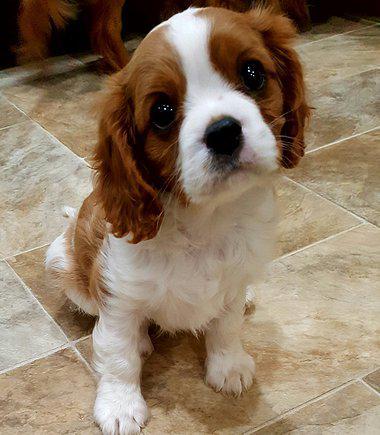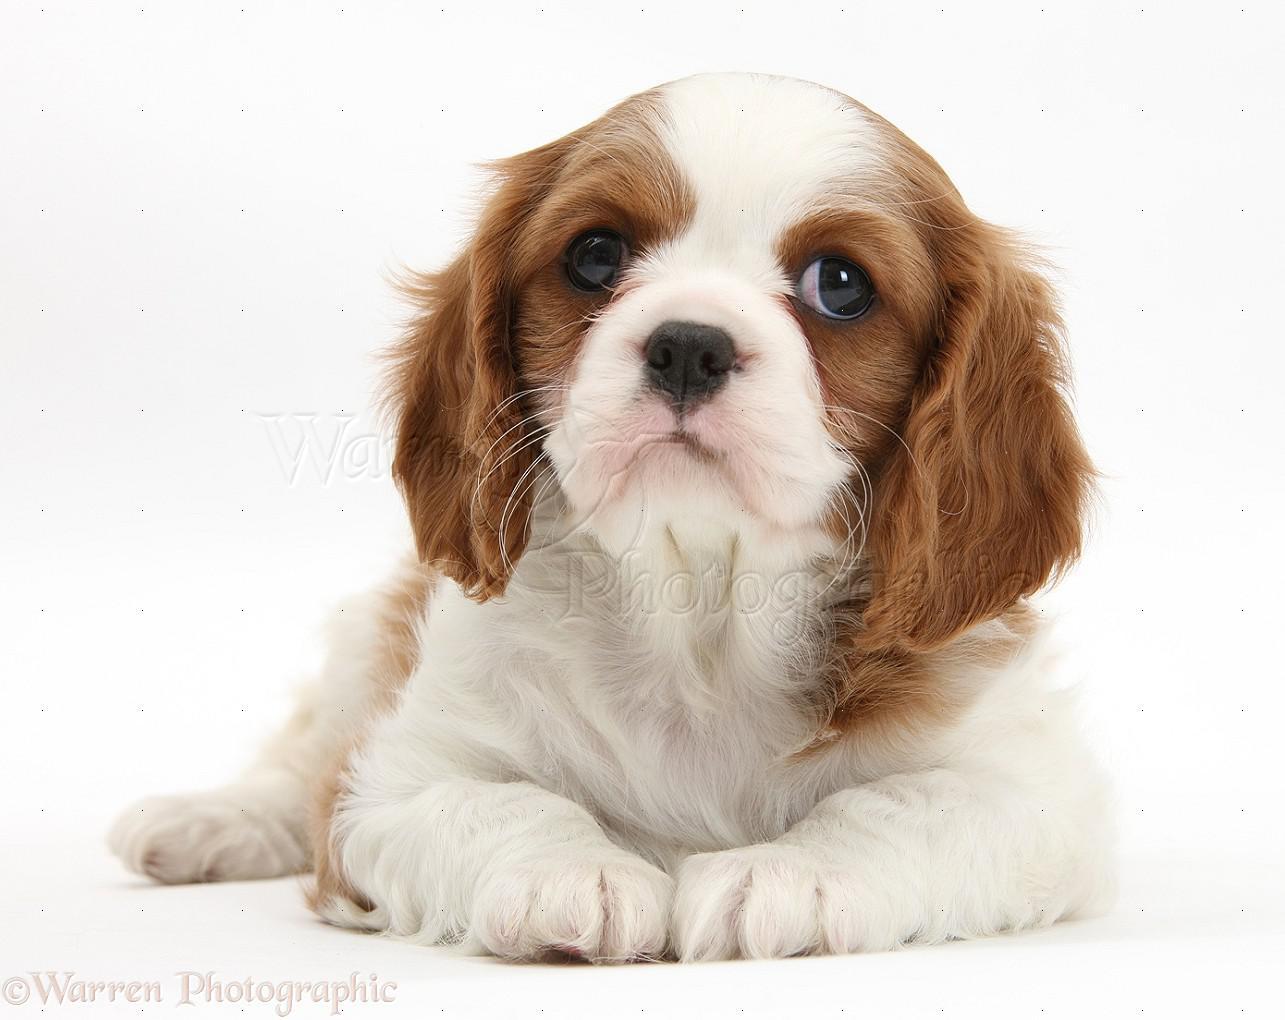The first image is the image on the left, the second image is the image on the right. For the images displayed, is the sentence "There is exactly one animal sitting in the image on the left." factually correct? Answer yes or no. Yes. 